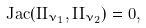<formula> <loc_0><loc_0><loc_500><loc_500>J a c ( I I _ { \nu _ { 1 } } , I I _ { \nu _ { 2 } } ) = 0 ,</formula> 